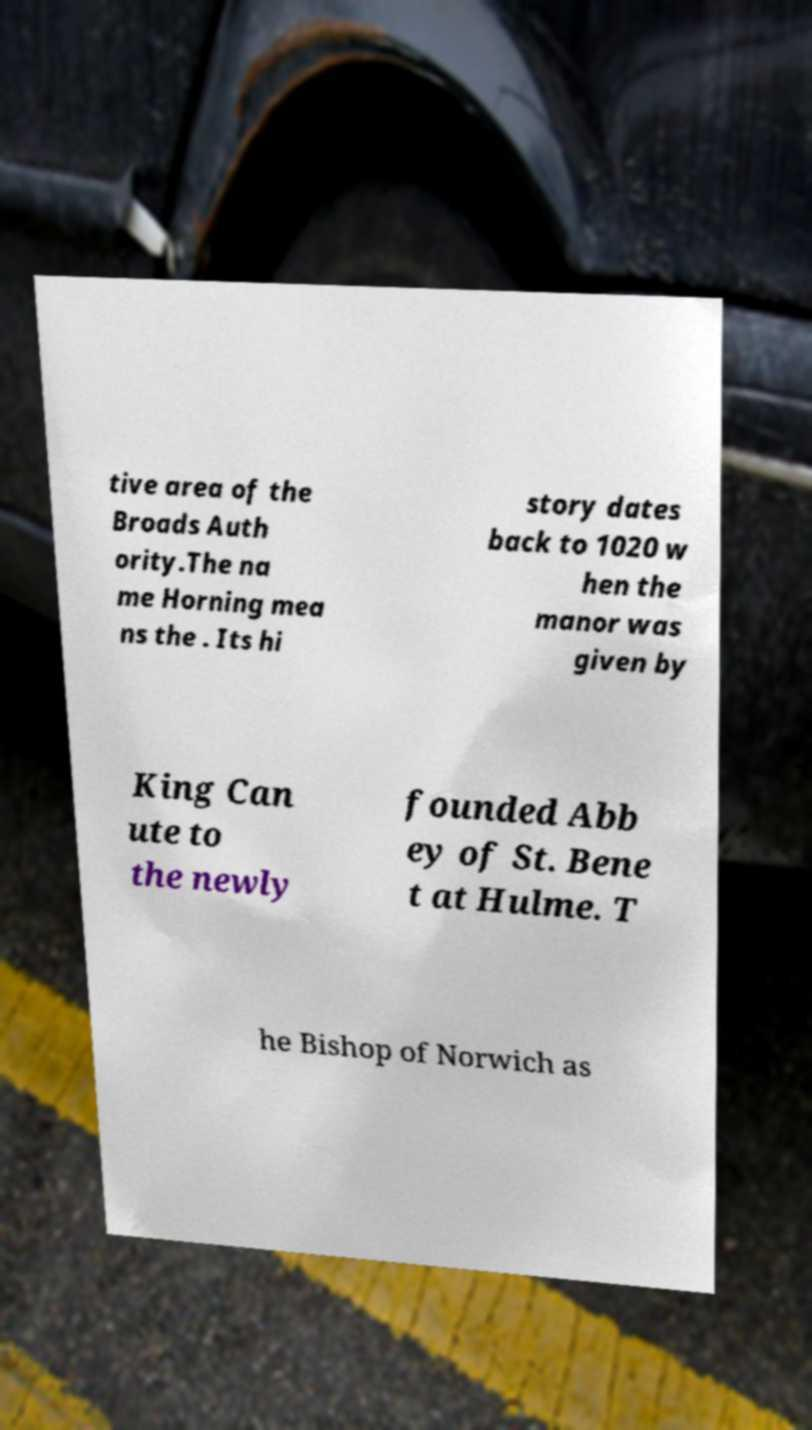Could you assist in decoding the text presented in this image and type it out clearly? tive area of the Broads Auth ority.The na me Horning mea ns the . Its hi story dates back to 1020 w hen the manor was given by King Can ute to the newly founded Abb ey of St. Bene t at Hulme. T he Bishop of Norwich as 